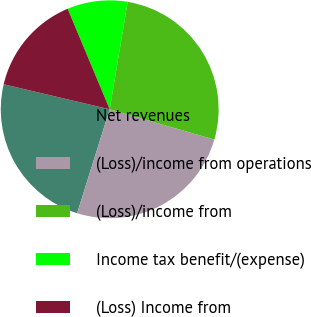<chart> <loc_0><loc_0><loc_500><loc_500><pie_chart><fcel>Net revenues<fcel>(Loss)/income from operations<fcel>(Loss)/income from<fcel>Income tax benefit/(expense)<fcel>(Loss) Income from<nl><fcel>23.85%<fcel>25.35%<fcel>26.85%<fcel>8.94%<fcel>15.01%<nl></chart> 